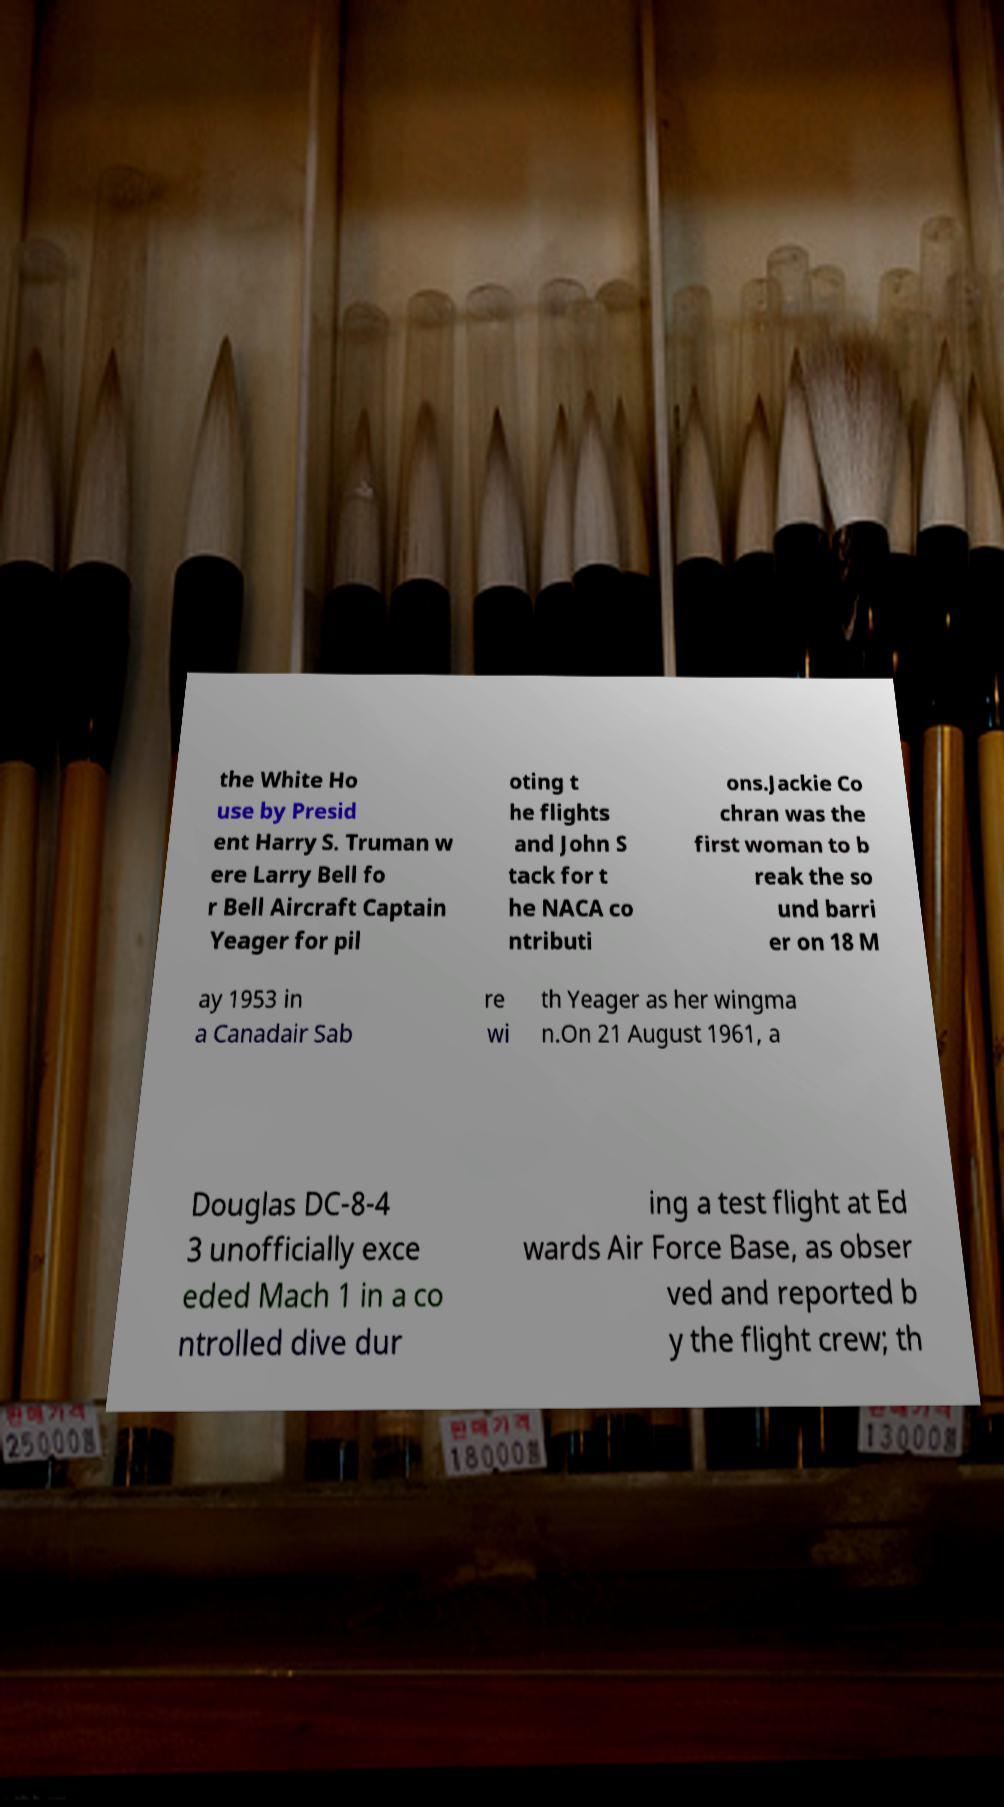Can you read and provide the text displayed in the image?This photo seems to have some interesting text. Can you extract and type it out for me? the White Ho use by Presid ent Harry S. Truman w ere Larry Bell fo r Bell Aircraft Captain Yeager for pil oting t he flights and John S tack for t he NACA co ntributi ons.Jackie Co chran was the first woman to b reak the so und barri er on 18 M ay 1953 in a Canadair Sab re wi th Yeager as her wingma n.On 21 August 1961, a Douglas DC-8-4 3 unofficially exce eded Mach 1 in a co ntrolled dive dur ing a test flight at Ed wards Air Force Base, as obser ved and reported b y the flight crew; th 